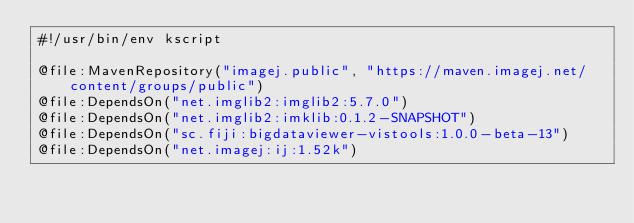Convert code to text. <code><loc_0><loc_0><loc_500><loc_500><_Kotlin_>#!/usr/bin/env kscript

@file:MavenRepository("imagej.public", "https://maven.imagej.net/content/groups/public")
@file:DependsOn("net.imglib2:imglib2:5.7.0")
@file:DependsOn("net.imglib2:imklib:0.1.2-SNAPSHOT")
@file:DependsOn("sc.fiji:bigdataviewer-vistools:1.0.0-beta-13")
@file:DependsOn("net.imagej:ij:1.52k")</code> 